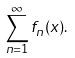Convert formula to latex. <formula><loc_0><loc_0><loc_500><loc_500>\sum _ { n = 1 } ^ { \infty } f _ { n } ( x ) .</formula> 